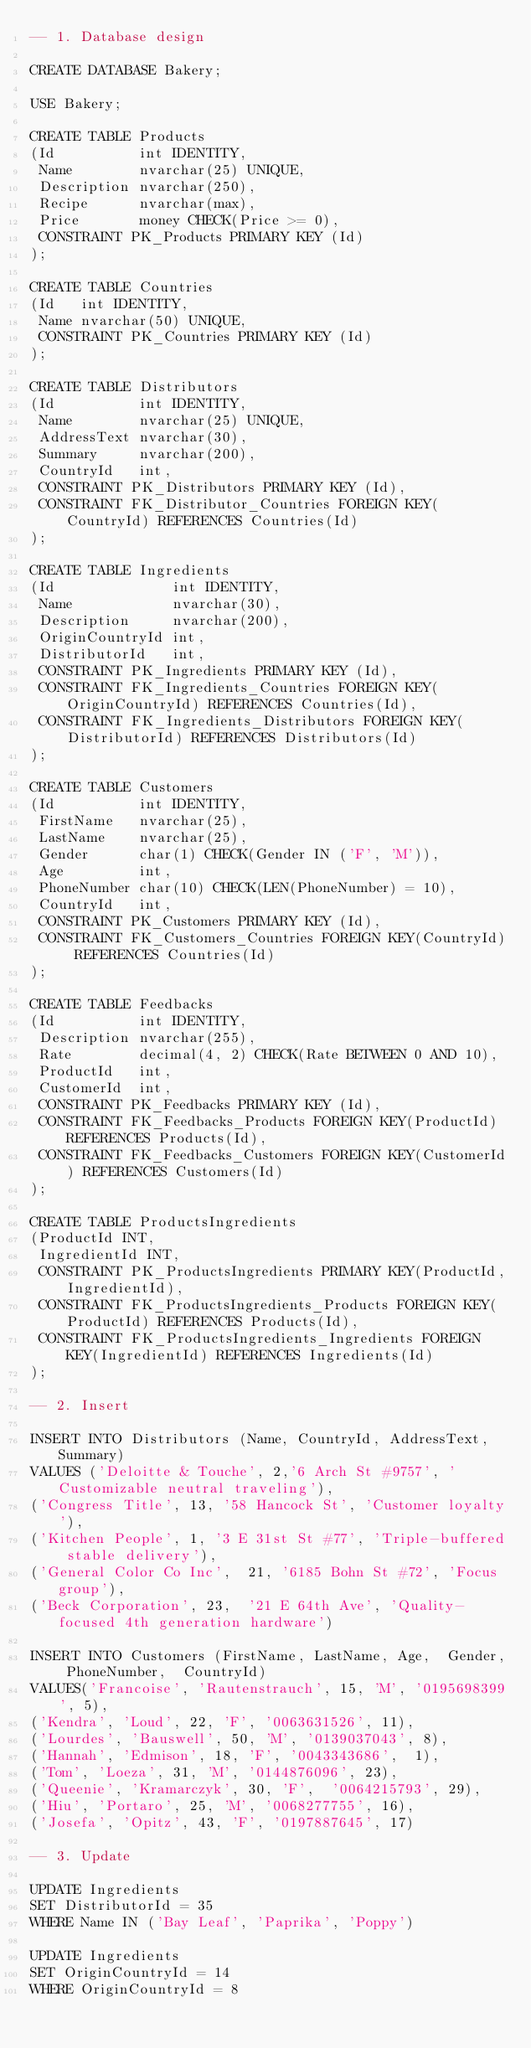Convert code to text. <code><loc_0><loc_0><loc_500><loc_500><_SQL_>-- 1. Database design

CREATE DATABASE Bakery;

USE Bakery;

CREATE TABLE Products
(Id          int IDENTITY,
 Name        nvarchar(25) UNIQUE,
 Description nvarchar(250),
 Recipe      nvarchar(max),
 Price       money CHECK(Price >= 0),
 CONSTRAINT PK_Products PRIMARY KEY (Id)
);

CREATE TABLE Countries
(Id   int IDENTITY,
 Name nvarchar(50) UNIQUE,
 CONSTRAINT PK_Countries PRIMARY KEY (Id)
);

CREATE TABLE Distributors
(Id          int IDENTITY,
 Name        nvarchar(25) UNIQUE,
 AddressText nvarchar(30),
 Summary     nvarchar(200),
 CountryId   int,
 CONSTRAINT PK_Distributors PRIMARY KEY (Id),
 CONSTRAINT FK_Distributor_Countries FOREIGN KEY(CountryId) REFERENCES Countries(Id)
);

CREATE TABLE Ingredients
(Id              int IDENTITY,
 Name            nvarchar(30),
 Description     nvarchar(200),
 OriginCountryId int,
 DistributorId   int,
 CONSTRAINT PK_Ingredients PRIMARY KEY (Id),
 CONSTRAINT FK_Ingredients_Countries FOREIGN KEY(OriginCountryId) REFERENCES Countries(Id),
 CONSTRAINT FK_Ingredients_Distributors FOREIGN KEY(DistributorId) REFERENCES Distributors(Id)
);

CREATE TABLE Customers
(Id          int IDENTITY,
 FirstName   nvarchar(25),
 LastName    nvarchar(25),
 Gender      char(1) CHECK(Gender IN ('F', 'M')),
 Age         int,
 PhoneNumber char(10) CHECK(LEN(PhoneNumber) = 10),
 CountryId   int,
 CONSTRAINT PK_Customers PRIMARY KEY (Id),
 CONSTRAINT FK_Customers_Countries FOREIGN KEY(CountryId) REFERENCES Countries(Id)
);

CREATE TABLE Feedbacks
(Id          int IDENTITY,
 Description nvarchar(255),
 Rate        decimal(4, 2) CHECK(Rate BETWEEN 0 AND 10),
 ProductId   int,
 CustomerId  int,
 CONSTRAINT PK_Feedbacks PRIMARY KEY (Id),
 CONSTRAINT FK_Feedbacks_Products FOREIGN KEY(ProductId) REFERENCES Products(Id),
 CONSTRAINT FK_Feedbacks_Customers FOREIGN KEY(CustomerId) REFERENCES Customers(Id)
);
 
CREATE TABLE ProductsIngredients
(ProductId INT, 
 IngredientId INT,
 CONSTRAINT PK_ProductsIngredients PRIMARY KEY(ProductId,IngredientId),
 CONSTRAINT FK_ProductsIngredients_Products FOREIGN KEY(ProductId) REFERENCES Products(Id),
 CONSTRAINT FK_ProductsIngredients_Ingredients FOREIGN KEY(IngredientId) REFERENCES Ingredients(Id)
);

-- 2. Insert

INSERT INTO Distributors (Name, CountryId, AddressText, Summary)
VALUES ('Deloitte & Touche', 2,'6 Arch St #9757',	'Customizable neutral traveling'),
('Congress Title', 13, '58 Hancock St',	'Customer loyalty'),
('Kitchen People', 1, '3 E 31st St #77', 'Triple-buffered stable delivery'),
('General Color Co Inc',	21, '6185 Bohn St #72', 'Focus group'),
('Beck Corporation', 23,	'21 E 64th Ave', 'Quality-focused 4th generation hardware')

INSERT INTO Customers (FirstName,	LastName,	Age,	Gender,	PhoneNumber,	CountryId)
VALUES('Francoise',	'Rautenstrauch', 15, 'M', '0195698399',	5),
('Kendra', 'Loud', 22, 'F', '0063631526', 11),
('Lourdes', 'Bauswell', 50, 'M', '0139037043', 8),
('Hannah', 'Edmison', 18, 'F', '0043343686',	1),
('Tom', 'Loeza', 31, 'M', '0144876096',	23),
('Queenie', 'Kramarczyk', 30,	'F',	'0064215793', 29),
('Hiu', 'Portaro', 25, 'M', '0068277755', 16),
('Josefa', 'Opitz',	43, 'F', '0197887645', 17)

-- 3. Update

UPDATE Ingredients
SET DistributorId = 35
WHERE Name IN ('Bay Leaf', 'Paprika', 'Poppy') 

UPDATE Ingredients
SET OriginCountryId = 14
WHERE OriginCountryId = 8
</code> 